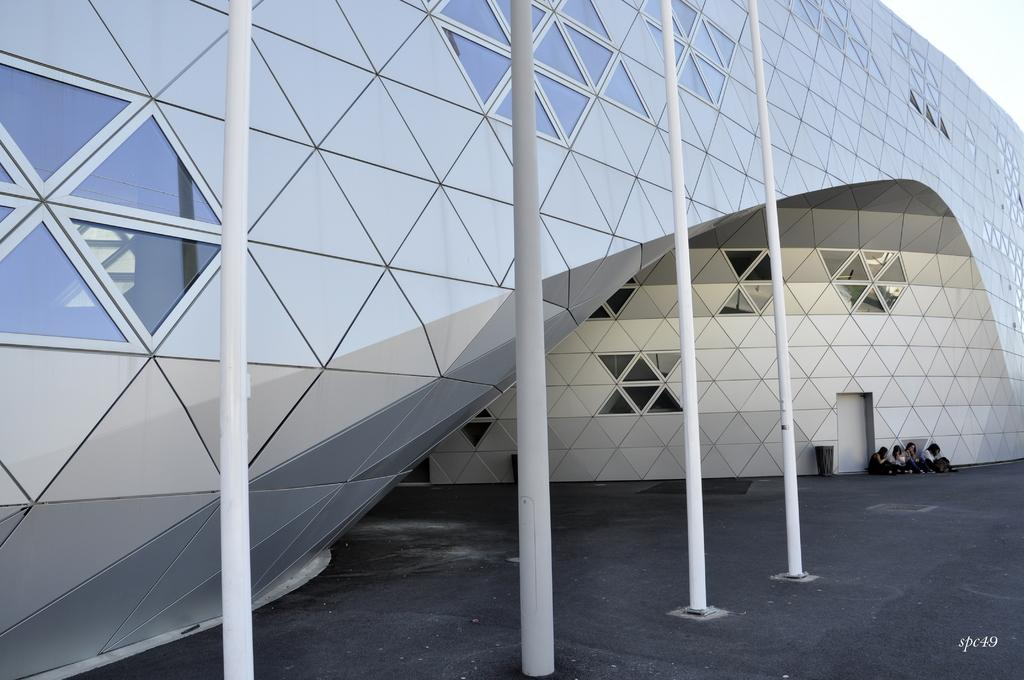What structures are present in the image? There are poles and a building in the image. Where are the people located in the image? The people are sitting on the right bottom side of the image. What is present in the bottom right corner of the image? There is a watermark in the bottom right corner of the image. What type of insect can be seen swimming in the watermark? There is no insect present in the image, and the watermark does not depict any water or swimming activity. 